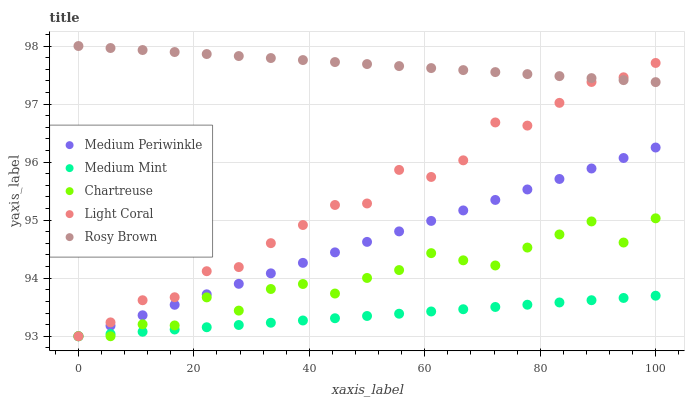Does Medium Mint have the minimum area under the curve?
Answer yes or no. Yes. Does Rosy Brown have the maximum area under the curve?
Answer yes or no. Yes. Does Light Coral have the minimum area under the curve?
Answer yes or no. No. Does Light Coral have the maximum area under the curve?
Answer yes or no. No. Is Rosy Brown the smoothest?
Answer yes or no. Yes. Is Chartreuse the roughest?
Answer yes or no. Yes. Is Light Coral the smoothest?
Answer yes or no. No. Is Light Coral the roughest?
Answer yes or no. No. Does Medium Mint have the lowest value?
Answer yes or no. Yes. Does Rosy Brown have the lowest value?
Answer yes or no. No. Does Rosy Brown have the highest value?
Answer yes or no. Yes. Does Light Coral have the highest value?
Answer yes or no. No. Is Medium Periwinkle less than Rosy Brown?
Answer yes or no. Yes. Is Rosy Brown greater than Medium Mint?
Answer yes or no. Yes. Does Light Coral intersect Chartreuse?
Answer yes or no. Yes. Is Light Coral less than Chartreuse?
Answer yes or no. No. Is Light Coral greater than Chartreuse?
Answer yes or no. No. Does Medium Periwinkle intersect Rosy Brown?
Answer yes or no. No. 